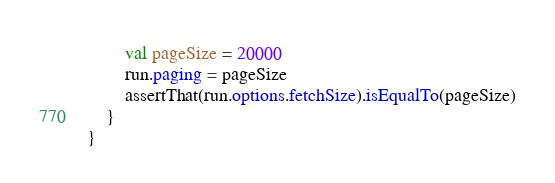<code> <loc_0><loc_0><loc_500><loc_500><_Kotlin_>        val pageSize = 20000
        run.paging = pageSize
        assertThat(run.options.fetchSize).isEqualTo(pageSize)
    }
}</code> 